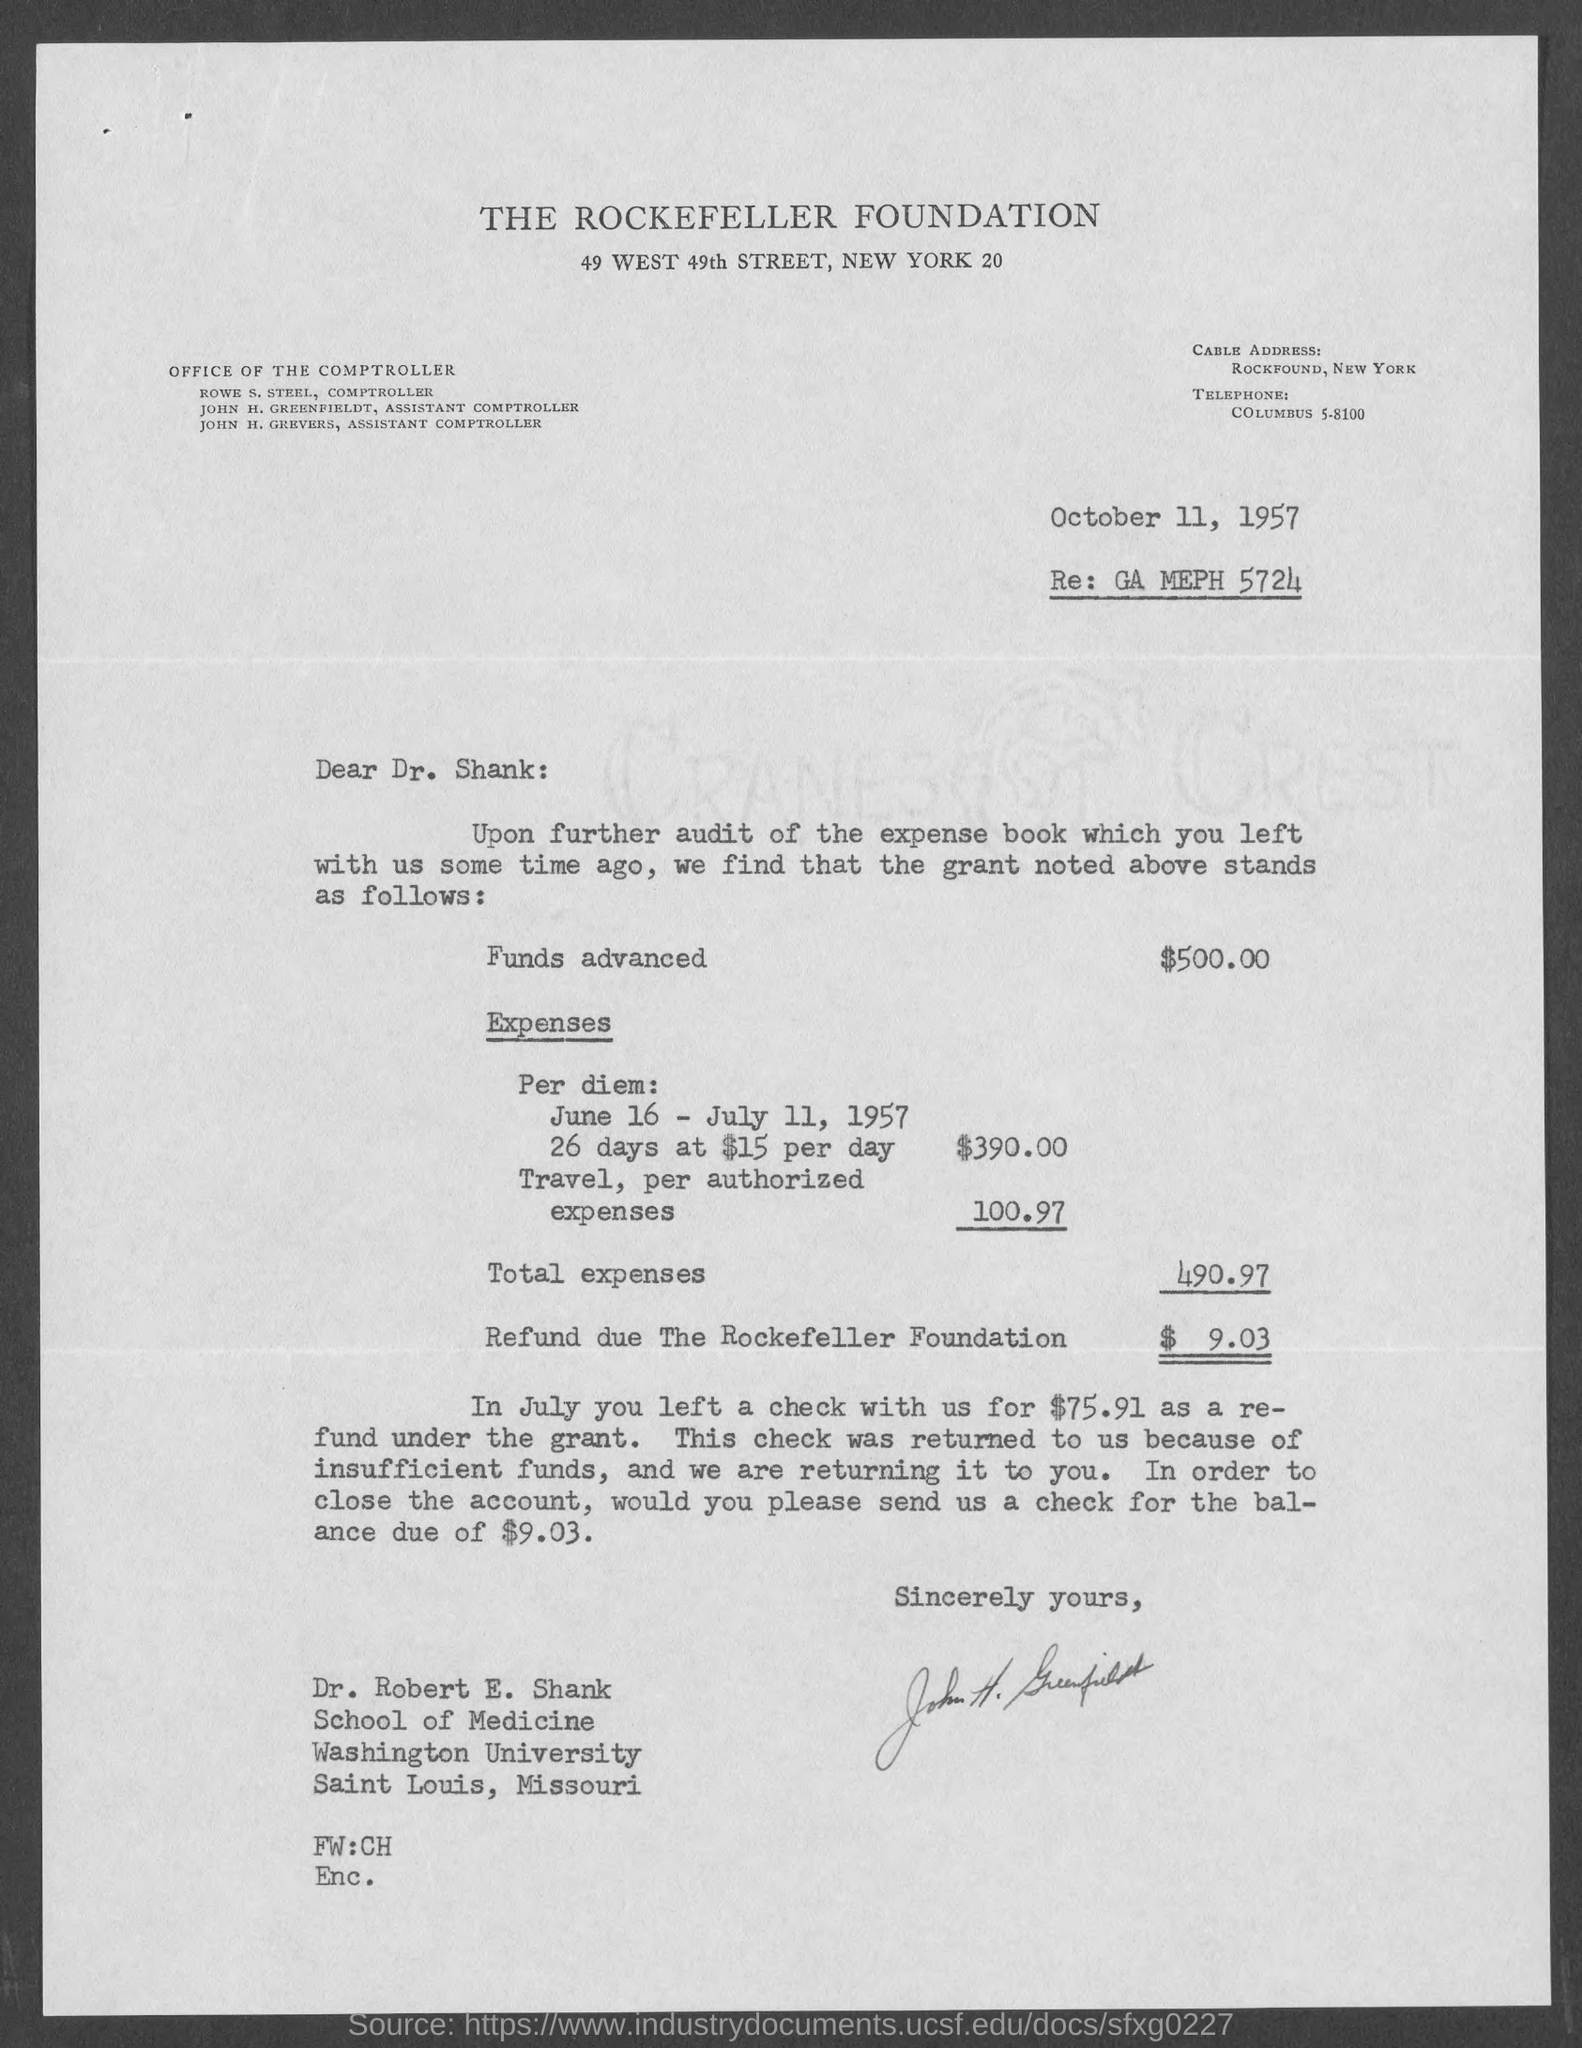Identify some key points in this picture. The text following the "Re:" in an email is GA MEPH 5724. The Rockefeller Foundation is entitled to a refund in the amount of $9.03. The funds are advanced for $500.00. The document is dated October 11, 1957. 